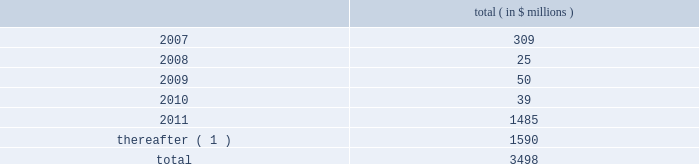2022 designate subsidiaries as unrestricted subsidiaries ; and 2022 sell certain assets or merge with or into other companies .
Subject to certain exceptions , the indentures governing the senior subordinated notes and the senior discount notes permit the issuers of the notes and their restricted subsidiaries to incur additional indebtedness , including secured indebtedness .
In addition , the senior credit facilities require bcp crystal to maintain the following financial covenants : a maximum total leverage ratio , a maximum bank debt leverage ratio , a minimum interest coverage ratio and maximum capital expenditures limitation .
The maximum consolidated net bank debt to adjusted ebitda ratio , as defined , previously required under the senior credit facilities , was eliminated when the company amended the facilities in january 2005 .
As of december 31 , 2006 , the company was in compliance with all of the financial covenants related to its debt agreements .
Principal payments scheduled to be made on the company 2019s debt , including short term borrowings , is as follows : ( in $ millions ) .
( 1 ) includes $ 2 million purchase accounting adjustment to assumed debt .
17 .
Benefit obligations pension obligations .
Pension obligations are established for benefits payable in the form of retirement , disability and surviving dependent pensions .
The benefits offered vary according to the legal , fiscal and economic conditions of each country .
The commitments result from participation in defined contribution and defined benefit plans , primarily in the u.s .
Benefits are dependent on years of service and the employee 2019s compensation .
Supplemental retirement benefits provided to certain employees are non-qualified for u.s .
Tax purposes .
Separate trusts have been established for some non-qualified plans .
The company sponsors defined benefit pension plans in north america , europe and asia .
As of december 31 , 2006 , the company 2019s u.s .
Qualified pension plan represented greater than 84% ( 84 % ) and 76% ( 76 % ) of celanese 2019s pension plan assets and liabilities , respectively .
Independent trusts or insurance companies administer the majority of these plans .
Pension costs under the company 2019s retirement plans are actuarially determined .
The company sponsors various defined contribution plans in north america , europe , and asia covering certain employees .
Employees may contribute to these plans and the company will match these contributions in varying amounts .
The company 2019s matching contribution to the defined contribution plans are based on specified percentages of employee contributions and aggregated $ 11 million , $ 12 million , $ 8 million and $ 3 million for the years ended december 31 , 2006 and 2005 , the nine months ended december 31 , 2004 and the three months ended march 31 , 2004 , respectively .
Celanese corporation and subsidiaries notes to consolidated financial statements 2014 ( continued ) .
What is the percent of the principal payments scheduled after 2011 to the total amount? 
Rationale: the percent is the amount divided total
Computations: (1590 / 3498)
Answer: 0.45455. 